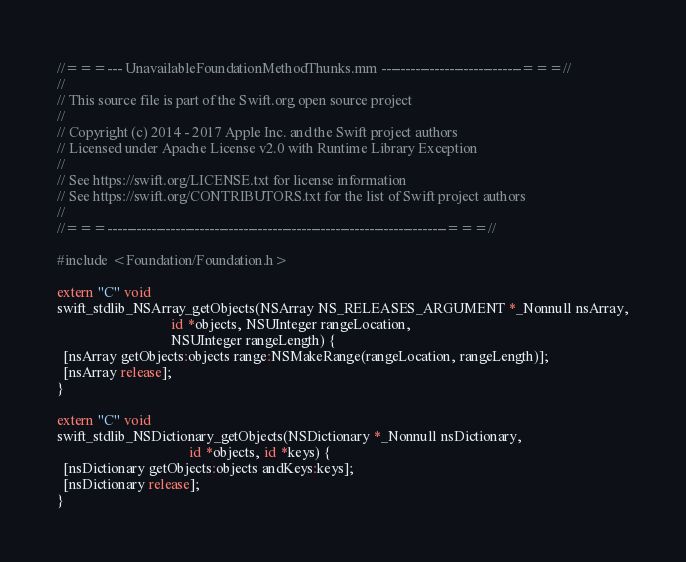Convert code to text. <code><loc_0><loc_0><loc_500><loc_500><_ObjectiveC_>//===--- UnavailableFoundationMethodThunks.mm -----------------------------===//
//
// This source file is part of the Swift.org open source project
//
// Copyright (c) 2014 - 2017 Apple Inc. and the Swift project authors
// Licensed under Apache License v2.0 with Runtime Library Exception
//
// See https://swift.org/LICENSE.txt for license information
// See https://swift.org/CONTRIBUTORS.txt for the list of Swift project authors
//
//===----------------------------------------------------------------------===//

#include <Foundation/Foundation.h>

extern "C" void
swift_stdlib_NSArray_getObjects(NSArray NS_RELEASES_ARGUMENT *_Nonnull nsArray,
                                id *objects, NSUInteger rangeLocation,
                                NSUInteger rangeLength) {
  [nsArray getObjects:objects range:NSMakeRange(rangeLocation, rangeLength)];
  [nsArray release];
}

extern "C" void
swift_stdlib_NSDictionary_getObjects(NSDictionary *_Nonnull nsDictionary,
                                     id *objects, id *keys) {
  [nsDictionary getObjects:objects andKeys:keys];
  [nsDictionary release];
}

</code> 